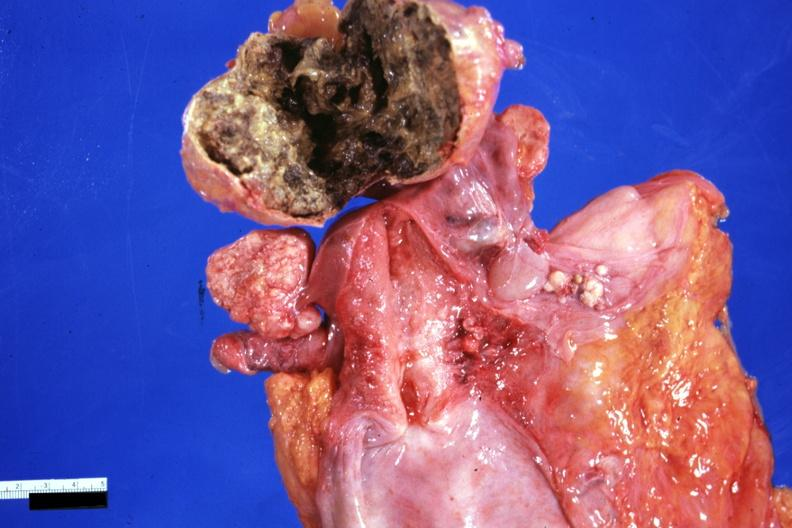s ovary present?
Answer the question using a single word or phrase. Yes 